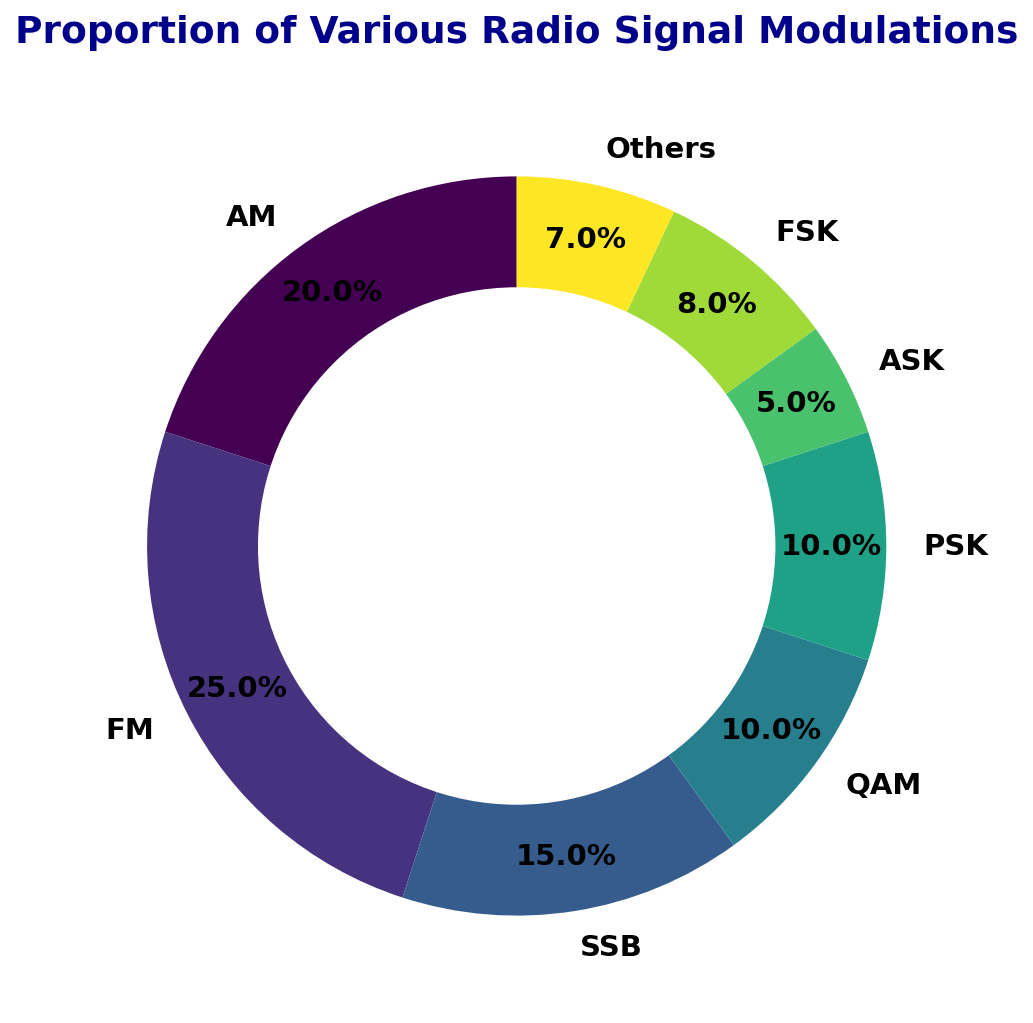what is the most common modulation type? By looking at the ring chart, the wedge that represents FM modulation occupies the largest proportion of the ring.
Answer: FM Which modulation types have an equal proportion in the given frequency band? The ring chart shows that PSK and QAM both have wedges of equal size, each having a proportion of 10%.
Answer: QAM and PSK What proportion of the band is occupied by FSK modulation? The wedge corresponding to FSK modulation is labeled with its proportion, 8%, as seen in the ring chart.
Answer: 8% Which modulation type is less than 10% but greater than 5% in the given band? Upon inspecting the chart, the wedge for FSK lies between 5% and 10%, specifically at 8%. The only other wedge within that range represents Others.
Answer: FSK and Others What is the combined proportion of AM and SSB modulations? The chart indicates that AM has a proportion of 20% and SSB has 15%. Summing these proportions (20 + 15) results in 35%.
Answer: 35% Which three modulation types together make up more than 50% of the band? Identifying the top three proportions: FM (25%), AM (20%), and SSB (15%). Summing these gives 25 + 20 + 15 = 60%, which is more than 50%.
Answer: FM, AM, and SSB Are there any modulation types that have less than 10% proportion? Observing the chart, the wedges for QAM, PSK, ASK, FSK, and Others all have proportions less than 10%.
Answer: QAM, PSK, ASK, FSK, and Others Which modulation type has the lowest representation in the band? Looking at the ring chart, ASK has the smallest wedge, which has a proportion of 5%.
Answer: ASK What is the difference in proportion between AM and FM modulations? The chart shows AM at 20% and FM at 25%. Calculating the difference, 25 - 20, results in 5%.
Answer: 5% How many modulation types occupy the frequency band? Counting the distinct wedges in the ring chart, there are eight modulation types represented.
Answer: 8 